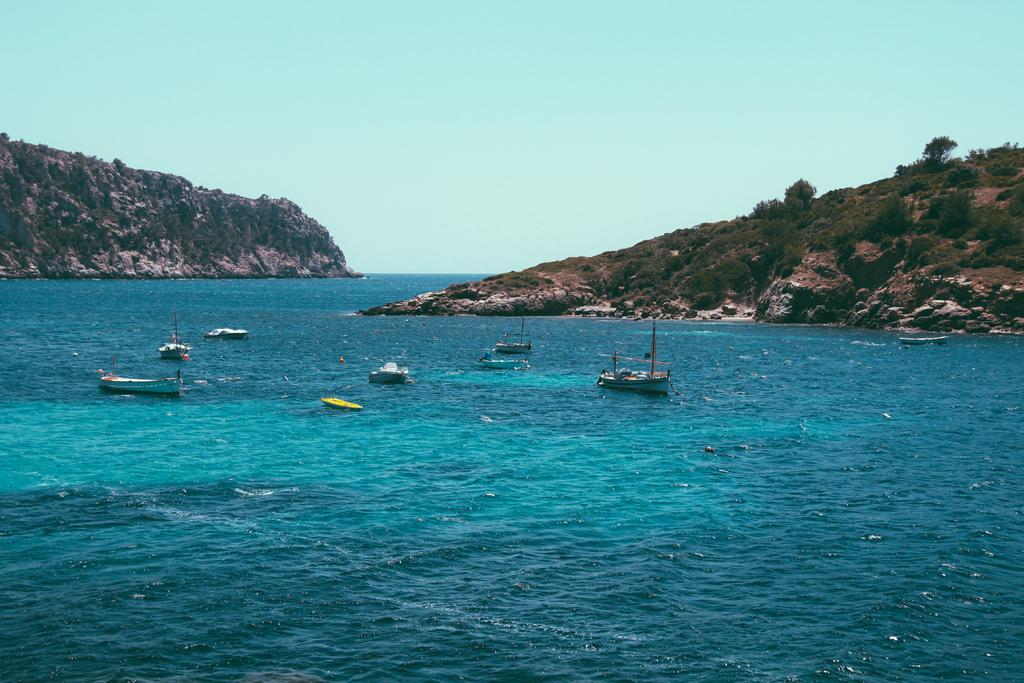What is happening on the water in the image? There are boats sailing on the water in the image. What geographical features can be seen in the background of the image? There are two mountains in the image. How are the mountains described in the image? The mountains are covered with trees and plants. What is the condition of the sky in the image? The sky is clear in the image. What role does the actor play in the image? There is no actor present in the image; it features boats sailing on the water and mountains covered with trees and plants. Is the son carrying a notebook in the image? There is no son or notebook present in the image. 